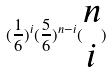<formula> <loc_0><loc_0><loc_500><loc_500>( \frac { 1 } { 6 } ) ^ { i } ( \frac { 5 } { 6 } ) ^ { n - i } ( \begin{matrix} n \\ i \end{matrix} )</formula> 